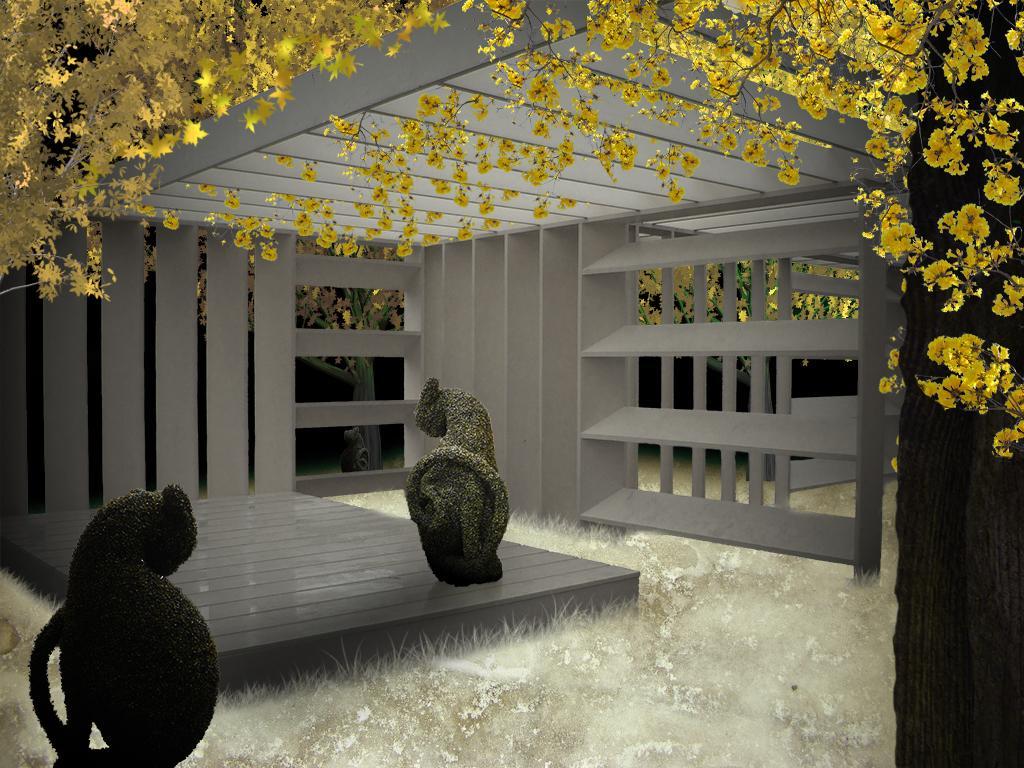Please provide a concise description of this image. This is looking like an edited image. On the right side there is a tree trunk. Here I can see few wooden racks. At the top of this image I can see the leaves and flowers which are in yellow color. 